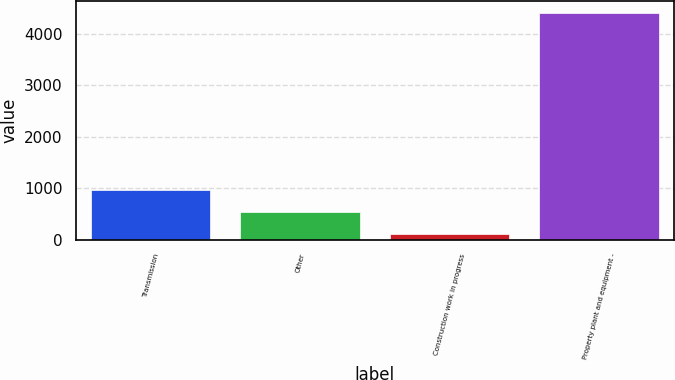Convert chart to OTSL. <chart><loc_0><loc_0><loc_500><loc_500><bar_chart><fcel>Transmission<fcel>Other<fcel>Construction work in progress<fcel>Property plant and equipment -<nl><fcel>973<fcel>543.5<fcel>114<fcel>4409<nl></chart> 